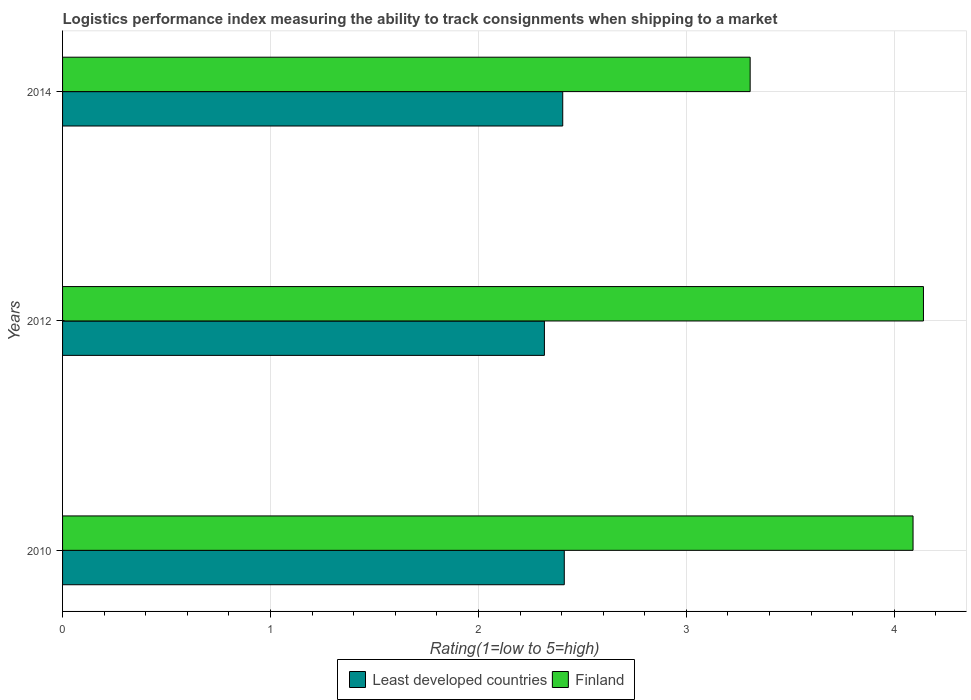How many groups of bars are there?
Your answer should be compact. 3. Are the number of bars on each tick of the Y-axis equal?
Keep it short and to the point. Yes. How many bars are there on the 3rd tick from the top?
Make the answer very short. 2. What is the label of the 3rd group of bars from the top?
Your answer should be very brief. 2010. What is the Logistic performance index in Finland in 2014?
Ensure brevity in your answer.  3.31. Across all years, what is the maximum Logistic performance index in Least developed countries?
Offer a terse response. 2.41. Across all years, what is the minimum Logistic performance index in Finland?
Offer a terse response. 3.31. In which year was the Logistic performance index in Least developed countries minimum?
Provide a short and direct response. 2012. What is the total Logistic performance index in Finland in the graph?
Keep it short and to the point. 11.54. What is the difference between the Logistic performance index in Least developed countries in 2010 and that in 2012?
Offer a terse response. 0.1. What is the difference between the Logistic performance index in Least developed countries in 2010 and the Logistic performance index in Finland in 2014?
Your response must be concise. -0.89. What is the average Logistic performance index in Finland per year?
Provide a short and direct response. 3.85. In the year 2014, what is the difference between the Logistic performance index in Least developed countries and Logistic performance index in Finland?
Provide a short and direct response. -0.9. In how many years, is the Logistic performance index in Least developed countries greater than 1.8 ?
Your response must be concise. 3. What is the ratio of the Logistic performance index in Finland in 2010 to that in 2012?
Make the answer very short. 0.99. Is the Logistic performance index in Least developed countries in 2012 less than that in 2014?
Ensure brevity in your answer.  Yes. What is the difference between the highest and the second highest Logistic performance index in Finland?
Provide a short and direct response. 0.05. What is the difference between the highest and the lowest Logistic performance index in Finland?
Provide a short and direct response. 0.83. Is the sum of the Logistic performance index in Finland in 2012 and 2014 greater than the maximum Logistic performance index in Least developed countries across all years?
Offer a terse response. Yes. What does the 1st bar from the top in 2010 represents?
Provide a succinct answer. Finland. What does the 2nd bar from the bottom in 2014 represents?
Offer a terse response. Finland. Are all the bars in the graph horizontal?
Give a very brief answer. Yes. Are the values on the major ticks of X-axis written in scientific E-notation?
Keep it short and to the point. No. Where does the legend appear in the graph?
Give a very brief answer. Bottom center. How are the legend labels stacked?
Provide a short and direct response. Horizontal. What is the title of the graph?
Offer a very short reply. Logistics performance index measuring the ability to track consignments when shipping to a market. Does "Egypt, Arab Rep." appear as one of the legend labels in the graph?
Your answer should be compact. No. What is the label or title of the X-axis?
Provide a short and direct response. Rating(1=low to 5=high). What is the Rating(1=low to 5=high) in Least developed countries in 2010?
Keep it short and to the point. 2.41. What is the Rating(1=low to 5=high) of Finland in 2010?
Your answer should be very brief. 4.09. What is the Rating(1=low to 5=high) in Least developed countries in 2012?
Provide a short and direct response. 2.32. What is the Rating(1=low to 5=high) of Finland in 2012?
Ensure brevity in your answer.  4.14. What is the Rating(1=low to 5=high) in Least developed countries in 2014?
Your answer should be compact. 2.41. What is the Rating(1=low to 5=high) in Finland in 2014?
Your answer should be very brief. 3.31. Across all years, what is the maximum Rating(1=low to 5=high) of Least developed countries?
Your response must be concise. 2.41. Across all years, what is the maximum Rating(1=low to 5=high) in Finland?
Your response must be concise. 4.14. Across all years, what is the minimum Rating(1=low to 5=high) in Least developed countries?
Make the answer very short. 2.32. Across all years, what is the minimum Rating(1=low to 5=high) of Finland?
Ensure brevity in your answer.  3.31. What is the total Rating(1=low to 5=high) of Least developed countries in the graph?
Your answer should be very brief. 7.14. What is the total Rating(1=low to 5=high) in Finland in the graph?
Provide a succinct answer. 11.54. What is the difference between the Rating(1=low to 5=high) of Least developed countries in 2010 and that in 2012?
Make the answer very short. 0.1. What is the difference between the Rating(1=low to 5=high) in Least developed countries in 2010 and that in 2014?
Your answer should be very brief. 0.01. What is the difference between the Rating(1=low to 5=high) in Finland in 2010 and that in 2014?
Your response must be concise. 0.78. What is the difference between the Rating(1=low to 5=high) of Least developed countries in 2012 and that in 2014?
Keep it short and to the point. -0.09. What is the difference between the Rating(1=low to 5=high) in Finland in 2012 and that in 2014?
Ensure brevity in your answer.  0.83. What is the difference between the Rating(1=low to 5=high) of Least developed countries in 2010 and the Rating(1=low to 5=high) of Finland in 2012?
Your response must be concise. -1.73. What is the difference between the Rating(1=low to 5=high) of Least developed countries in 2010 and the Rating(1=low to 5=high) of Finland in 2014?
Provide a short and direct response. -0.89. What is the difference between the Rating(1=low to 5=high) of Least developed countries in 2012 and the Rating(1=low to 5=high) of Finland in 2014?
Ensure brevity in your answer.  -0.99. What is the average Rating(1=low to 5=high) of Least developed countries per year?
Provide a short and direct response. 2.38. What is the average Rating(1=low to 5=high) of Finland per year?
Ensure brevity in your answer.  3.85. In the year 2010, what is the difference between the Rating(1=low to 5=high) of Least developed countries and Rating(1=low to 5=high) of Finland?
Give a very brief answer. -1.68. In the year 2012, what is the difference between the Rating(1=low to 5=high) in Least developed countries and Rating(1=low to 5=high) in Finland?
Offer a very short reply. -1.82. In the year 2014, what is the difference between the Rating(1=low to 5=high) of Least developed countries and Rating(1=low to 5=high) of Finland?
Make the answer very short. -0.9. What is the ratio of the Rating(1=low to 5=high) in Least developed countries in 2010 to that in 2012?
Give a very brief answer. 1.04. What is the ratio of the Rating(1=low to 5=high) of Finland in 2010 to that in 2012?
Keep it short and to the point. 0.99. What is the ratio of the Rating(1=low to 5=high) of Least developed countries in 2010 to that in 2014?
Offer a terse response. 1. What is the ratio of the Rating(1=low to 5=high) of Finland in 2010 to that in 2014?
Your response must be concise. 1.24. What is the ratio of the Rating(1=low to 5=high) of Least developed countries in 2012 to that in 2014?
Give a very brief answer. 0.96. What is the ratio of the Rating(1=low to 5=high) of Finland in 2012 to that in 2014?
Offer a very short reply. 1.25. What is the difference between the highest and the second highest Rating(1=low to 5=high) in Least developed countries?
Ensure brevity in your answer.  0.01. What is the difference between the highest and the lowest Rating(1=low to 5=high) in Least developed countries?
Provide a succinct answer. 0.1. What is the difference between the highest and the lowest Rating(1=low to 5=high) in Finland?
Your response must be concise. 0.83. 